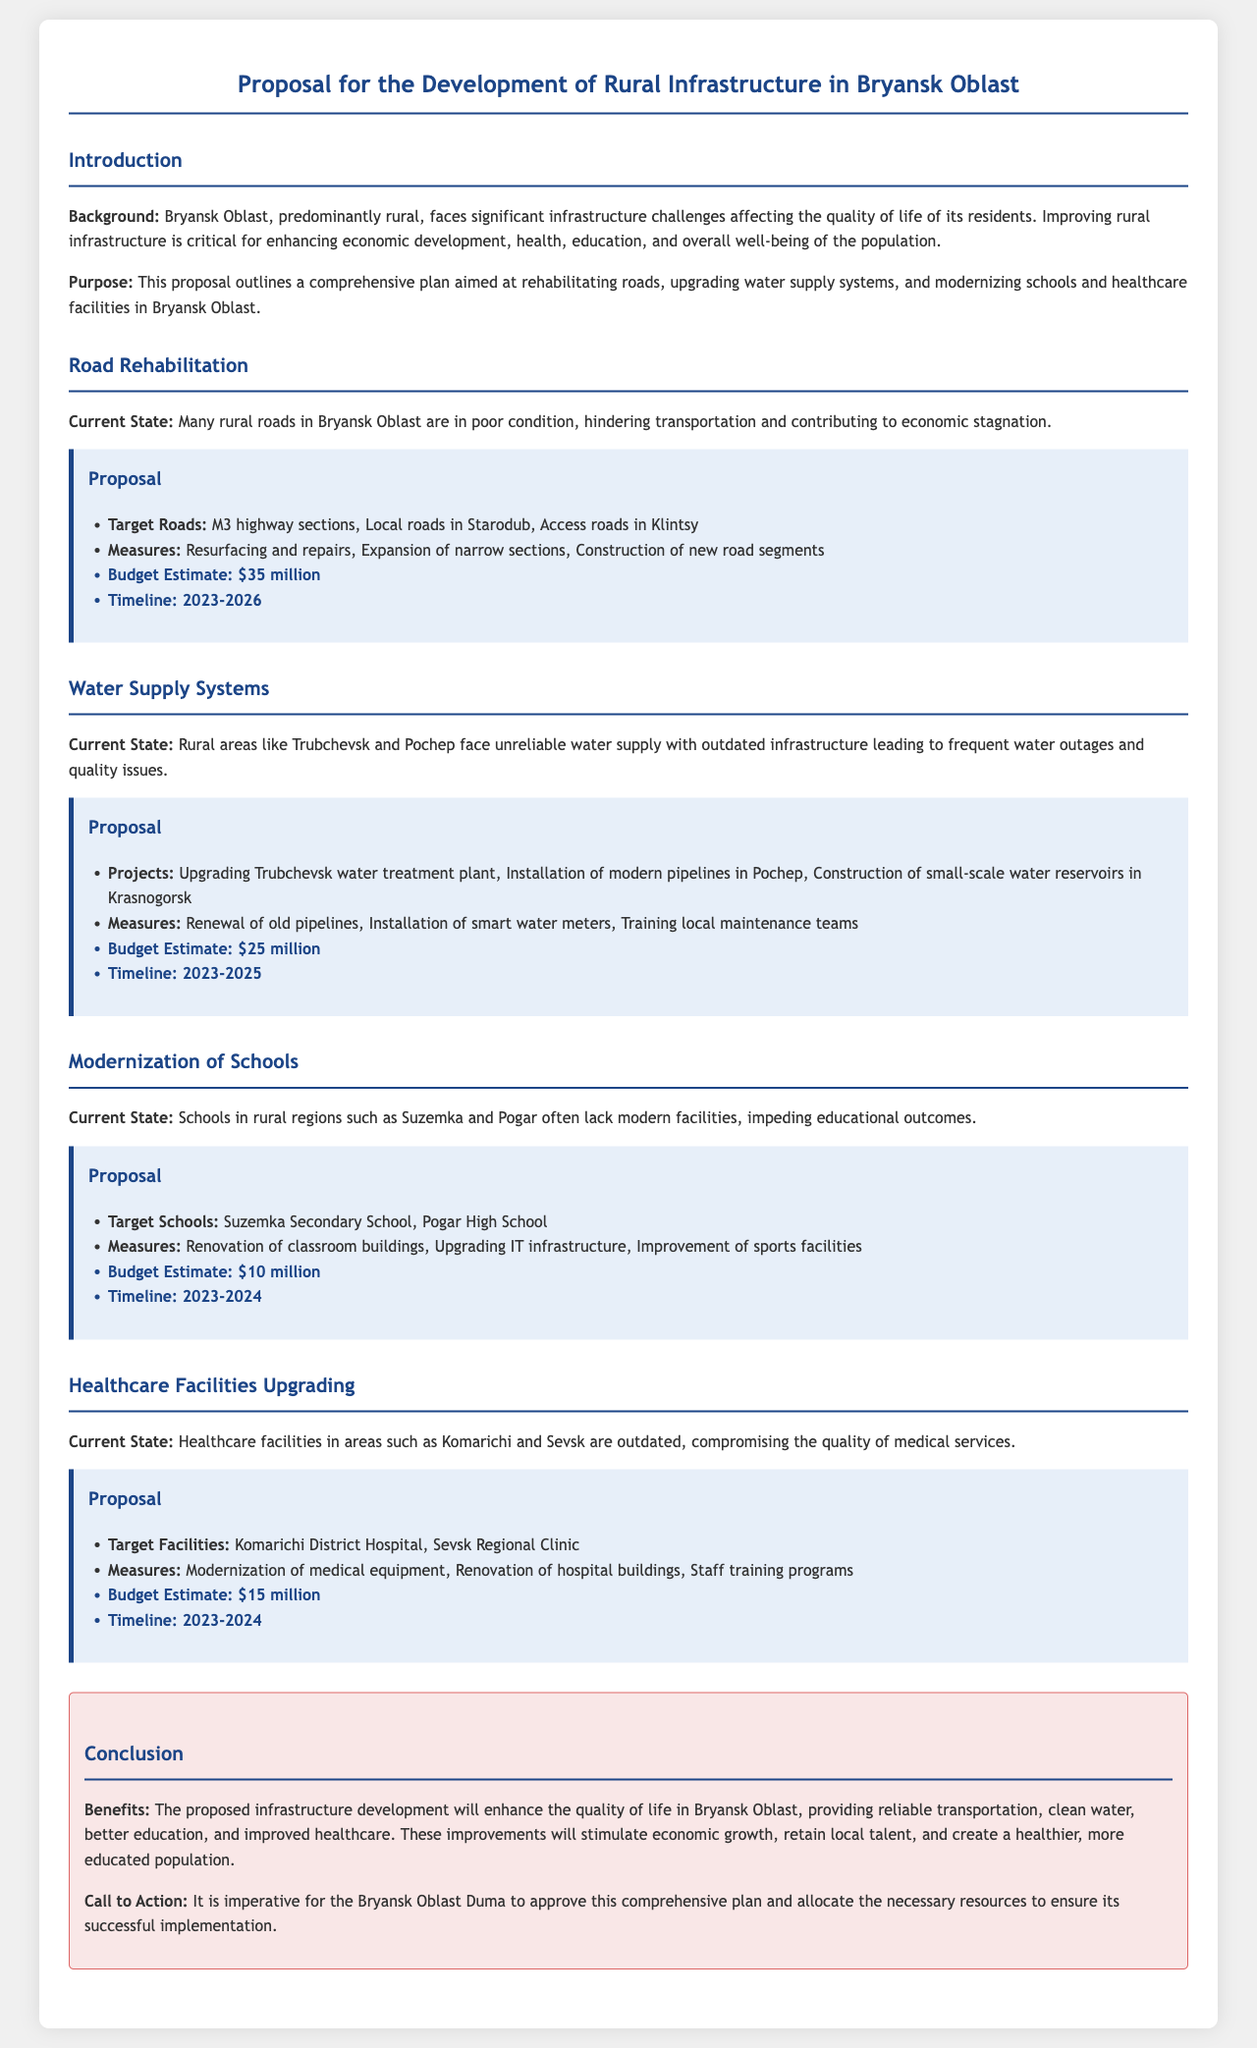What is the total budget estimate for road rehabilitation? The budget estimate for road rehabilitation is provided in the proposal under the Road Rehabilitation section, which is $35 million.
Answer: $35 million What is the timeline for upgrading water supply systems? The timeline for upgrading water supply systems is mentioned in the Water Supply Systems proposal as 2023-2025.
Answer: 2023-2025 Which school is targeted for modernization in Pogar? The targeted school for modernization in Pogar is specifically identified in the Modernization of Schools section as Pogar High School.
Answer: Pogar High School What are the measures proposed for healthcare facilities? The measures proposed for healthcare facilities are listed in the Healthcare Facilities Upgrading section, including modernizing medical equipment and renovating hospital buildings.
Answer: Modernization of medical equipment, Renovation of hospital buildings, Staff training programs What is the current state of rural roads in Bryansk Oblast? The current state of rural roads is described in the Road Rehabilitation section, stating that many rural roads are in poor condition, hindering transportation and economic growth.
Answer: Poor condition What is the budget estimate for the modernization of schools? The document specifies the budget estimate for the modernization of schools found in the Modernization of Schools section, which is $10 million.
Answer: $10 million What is the target water supply project mentioned in Trubchevsk? The target water supply project mentioned for Trubchevsk includes upgrading the water treatment plant, as stated in the Water Supply Systems section.
Answer: Upgrading Trubchevsk water treatment plant What benefits are outlined in the conclusion? The conclusion discusses benefits focusing on enhancing quality of life, reliable transportation, clean water, and better education among others.
Answer: Enhance quality of life, provide reliable transportation, clean water, better education How many rural areas are specifically named in the document? The document names rural areas specifically mentioned throughout its sections—Trubchevsk, Pochep, Suzemka, Pogar, Komarichi, and Sevsk, indicating a total of six.
Answer: Six 